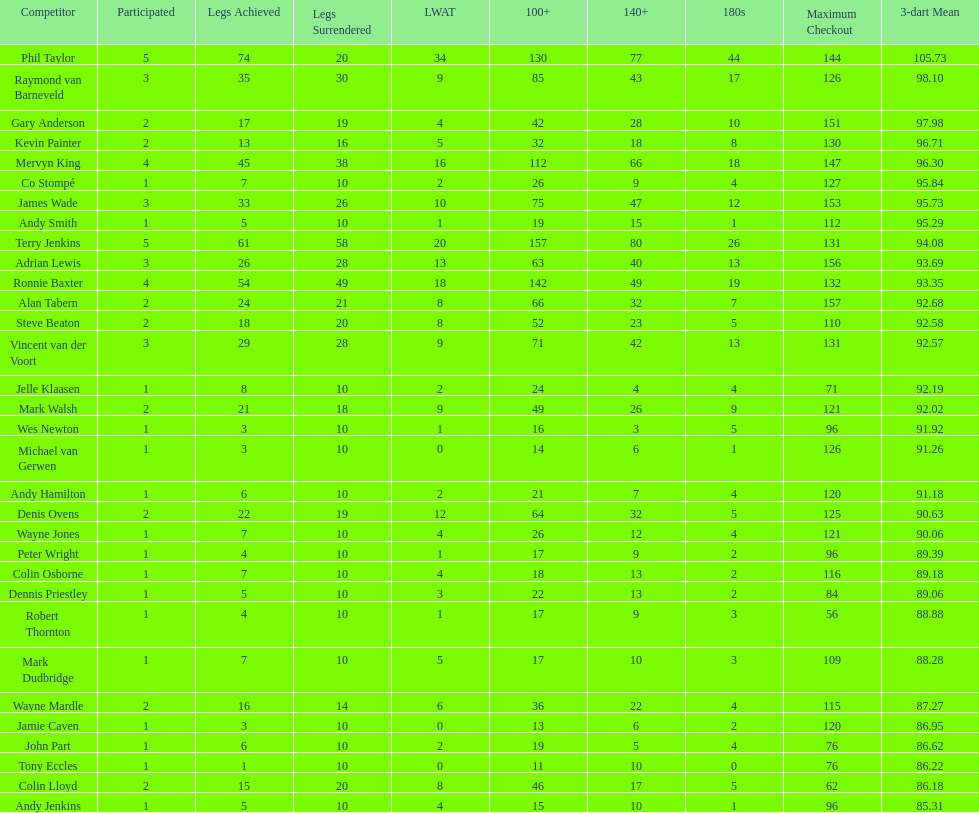How many legs has james wade lost? 26. 